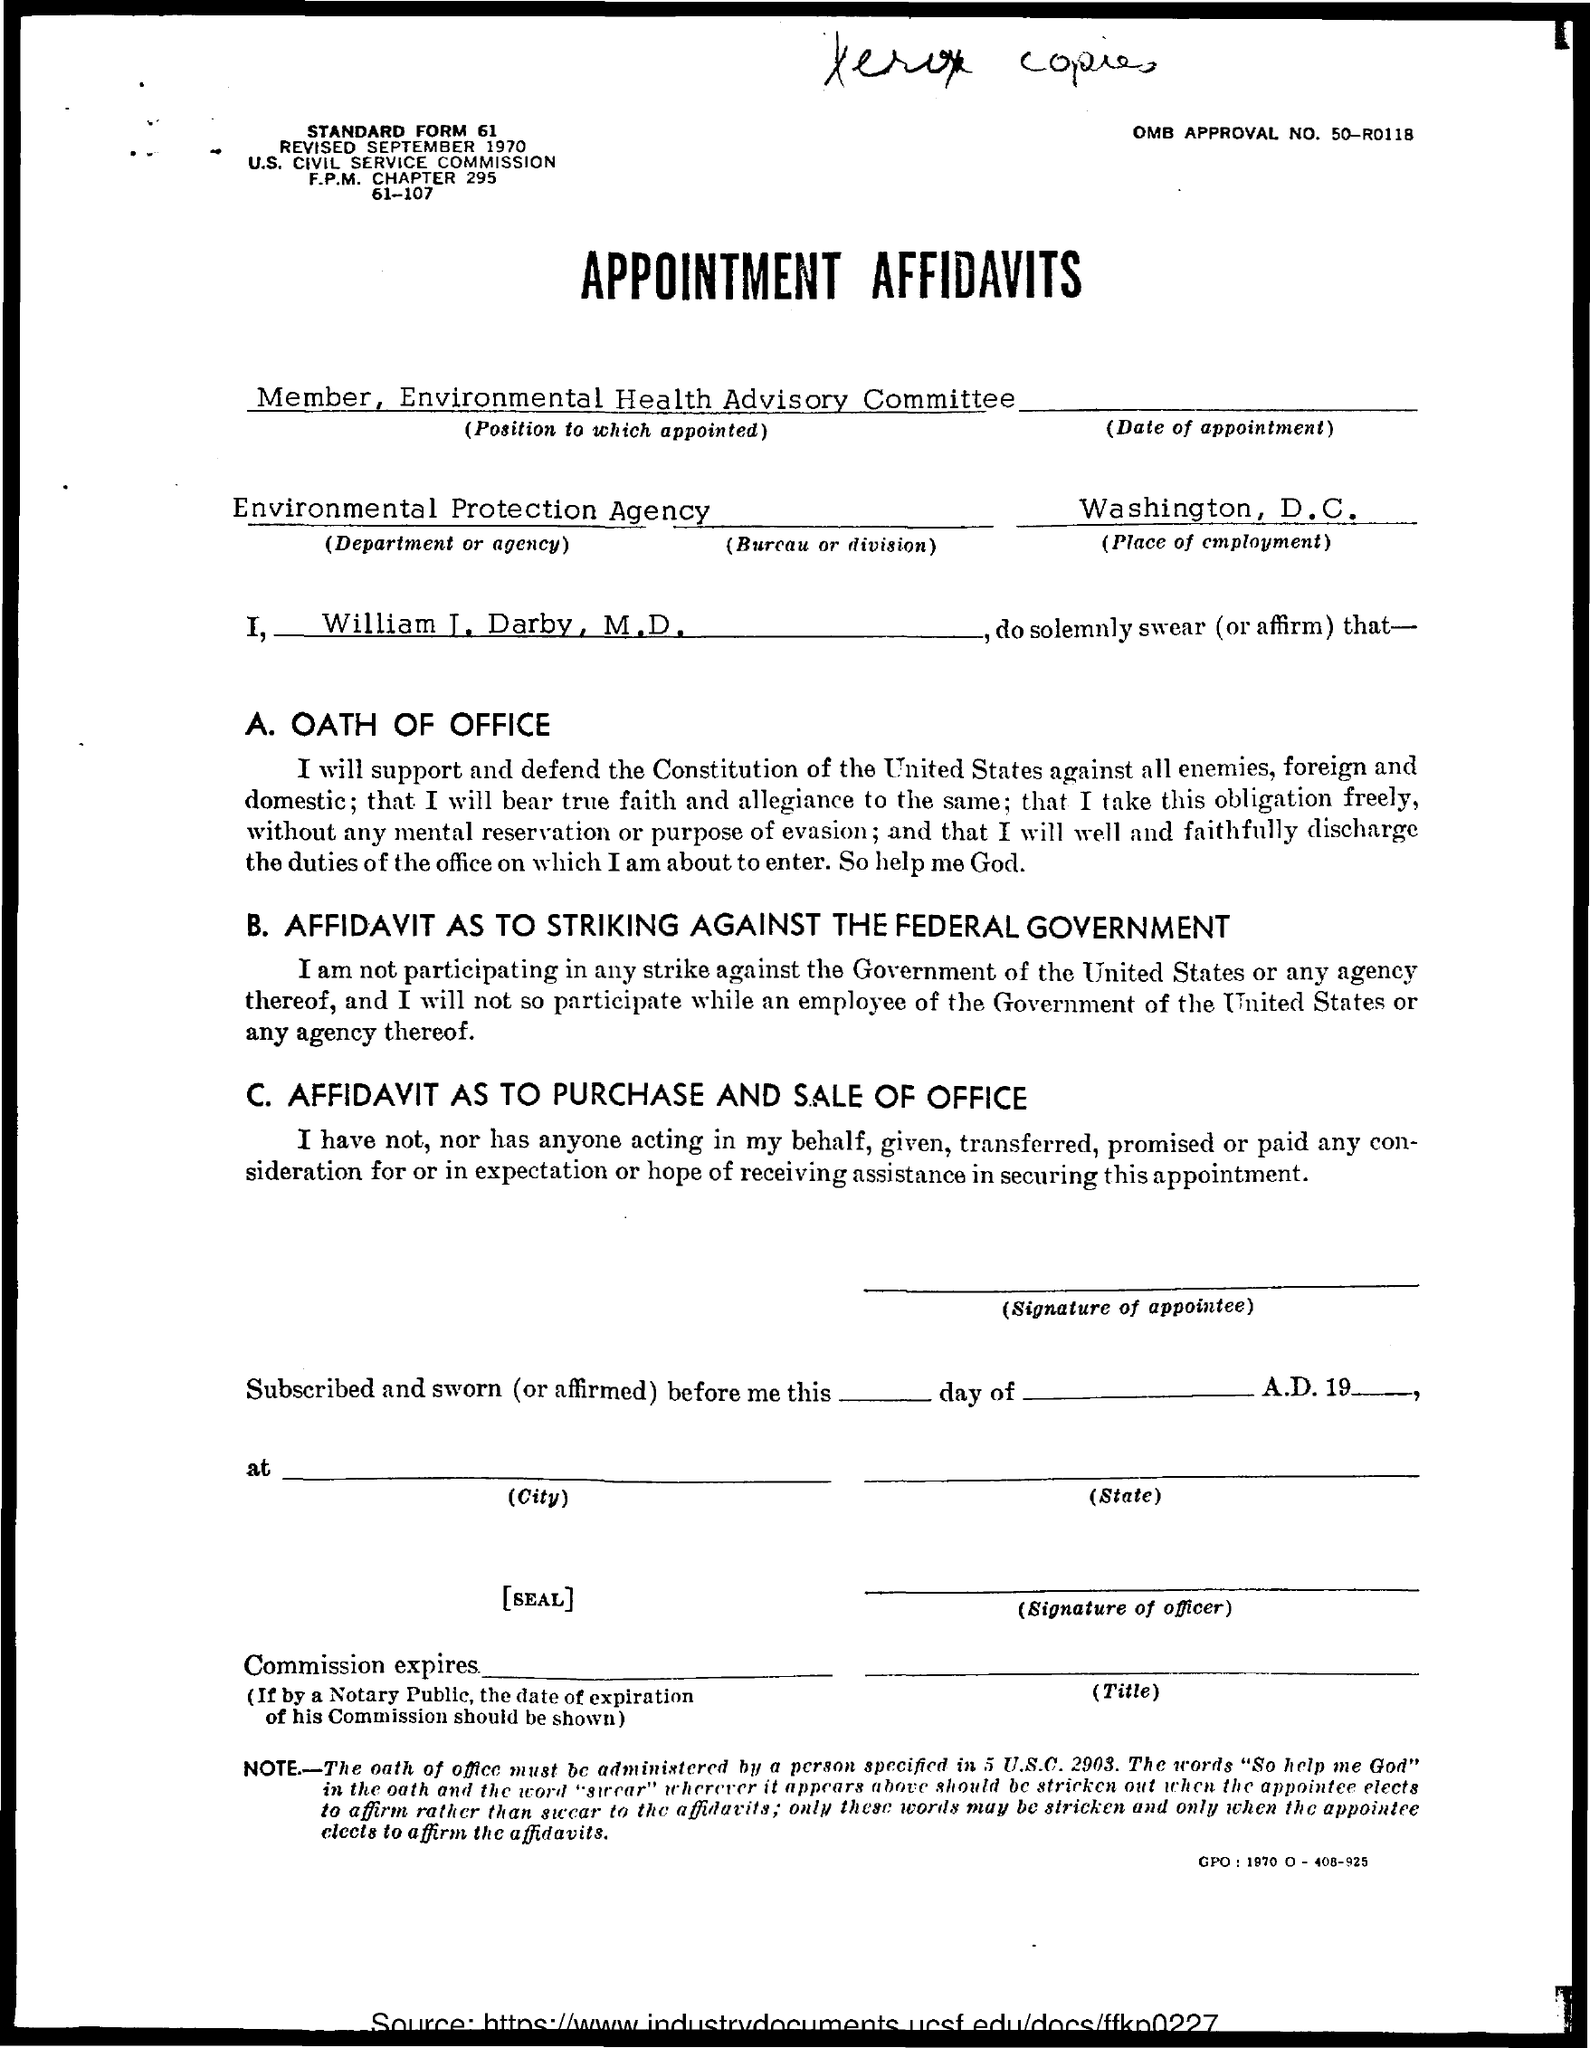What is the name of applicant?
Provide a short and direct response. William j. darby, m.d. What is the place of employment ?
Provide a succinct answer. Washington, D.C. 